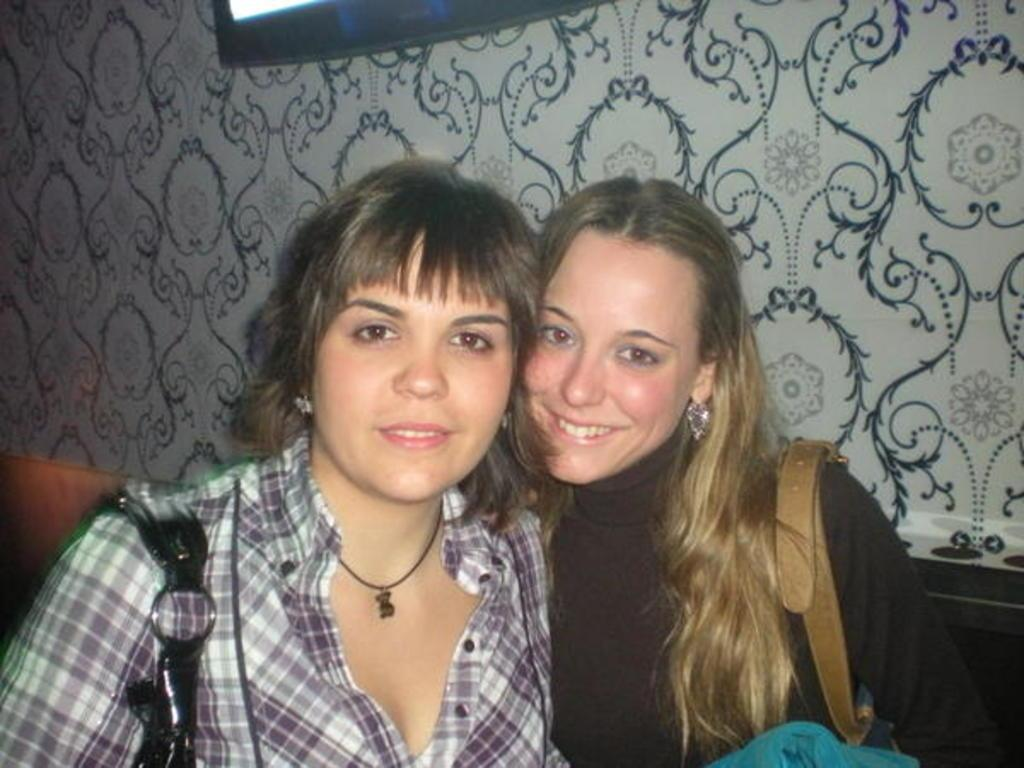How many people are in the image? There are two girls in the image. What are the girls doing in the image? The girls are sitting together on a couch. What is the facial expression of the girls in the image? The girls are smiling. What type of polish is the bird using on the truck in the image? There is no bird or truck present in the image, and therefore no polish or related activity can be observed. 